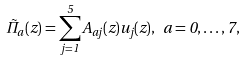<formula> <loc_0><loc_0><loc_500><loc_500>\tilde { \Pi } _ { a } ( z ) = \sum _ { j = 1 } ^ { 5 } A _ { a j } ( z ) u _ { j } ( z ) , \ a = 0 , \dots , 7 ,</formula> 